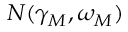Convert formula to latex. <formula><loc_0><loc_0><loc_500><loc_500>N ( \gamma _ { M } , \omega _ { M } )</formula> 